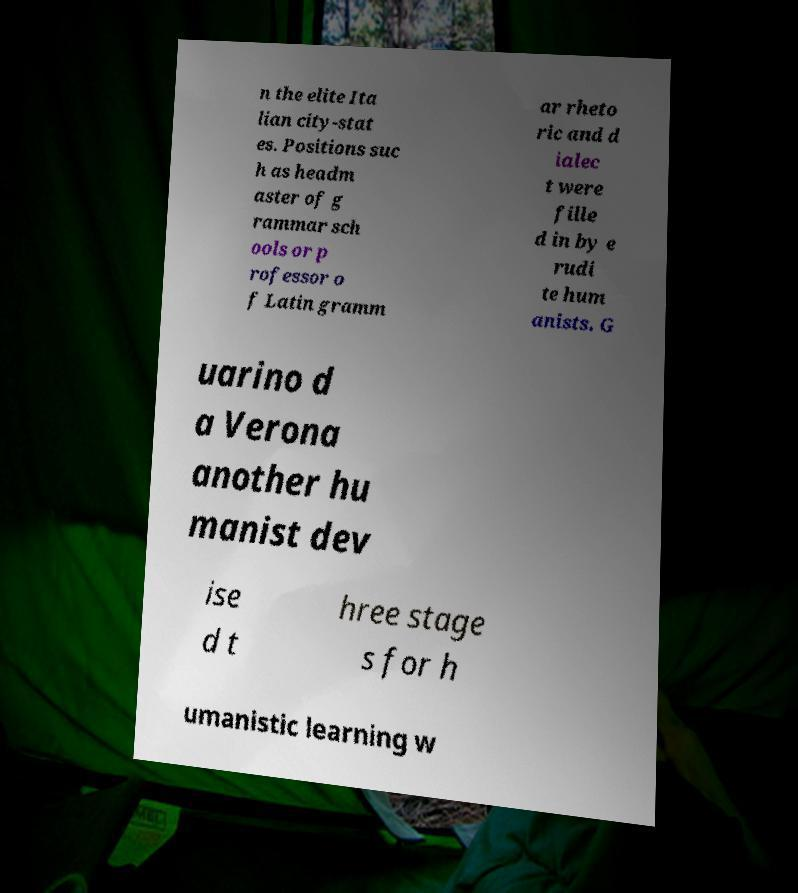Please identify and transcribe the text found in this image. n the elite Ita lian city-stat es. Positions suc h as headm aster of g rammar sch ools or p rofessor o f Latin gramm ar rheto ric and d ialec t were fille d in by e rudi te hum anists. G uarino d a Verona another hu manist dev ise d t hree stage s for h umanistic learning w 